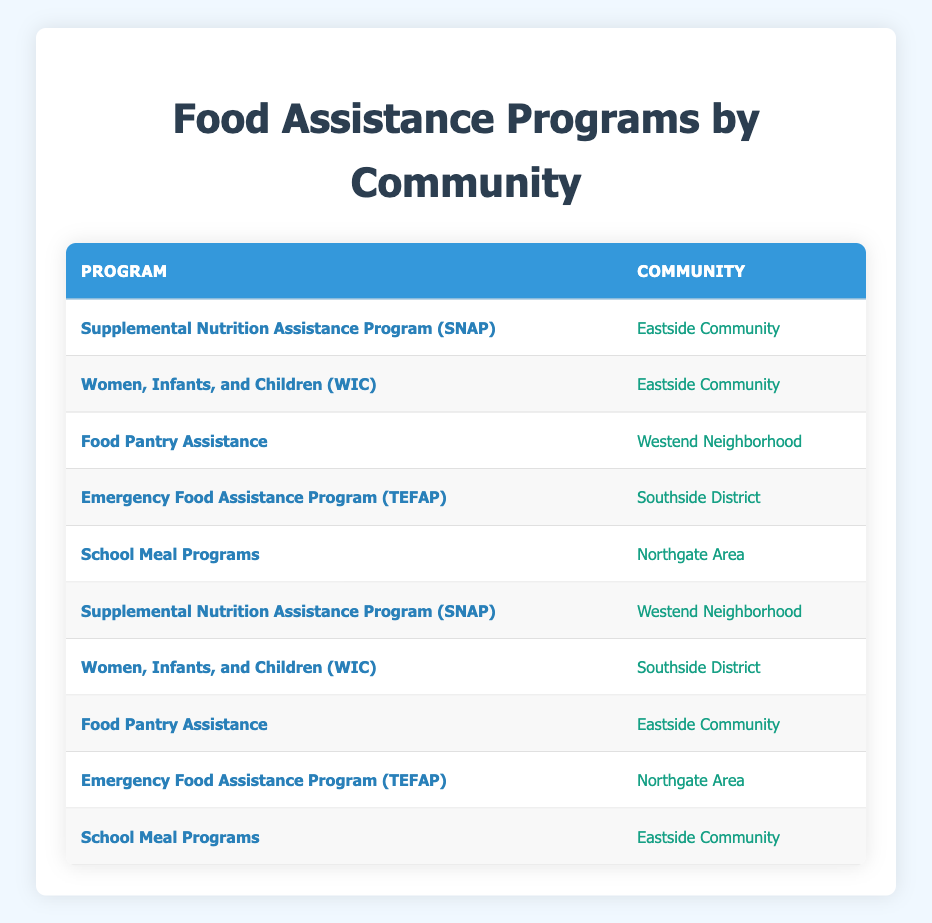What is the most utilized food assistance program in the table? The table lists several food assistance programs, and counting them shows that the "Supplemental Nutrition Assistance Program (SNAP)" appears twice, while all other programs appear once. Therefore, SNAP is the most utilized program.
Answer: Supplemental Nutrition Assistance Program (SNAP) How many households in the Eastside Community are using the "Women, Infants, and Children (WIC)" program? The table shows that "Women, Infants, and Children (WIC)" is listed once under the Eastside Community, indicating that only one household in that community is using this program.
Answer: 1 Are there any households utilizing food assistance programs in the Northgate Area? Yes, the table shows that the "School Meal Programs" and "Emergency Food Assistance Program (TEFAP)" are both used by households in the Northgate Area.
Answer: Yes Which community has the most varied range of food assistance programs utilized? Counting the different programs in each community, the Eastside Community has three different programs ("SNAP," "WIC," and "Food Pantry Assistance"), while the other communities have fewer. Therefore, Eastside has the most variety in food assistance programs.
Answer: Eastside Community How many different food assistance programs are listed in total in the table? The table displays a total of five unique programs: "Supplemental Nutrition Assistance Program (SNAP)", "Women, Infants, and Children (WIC)", "Food Pantry Assistance," "Emergency Food Assistance Program (TEFAP)," and "School Meal Programs." Thus, there are five different programs listed.
Answer: 5 Does the Westend Neighborhood utilize the "School Meal Programs"? No, the table does not indicate that the Westend Neighborhood has any households using the "School Meal Programs." The only programs listed for this community are "Food Pantry Assistance" and "SNAP."
Answer: No What is the total number of households utilizing "Emergency Food Assistance Program (TEFAP)" across all communities? The table shows that "Emergency Food Assistance Program (TEFAP)" is listed twice—once for the Southside District and once for the Northgate Area. Adding these two instances gives us a total of two households using this program.
Answer: 2 Which food assistance program is the only one to appear in the Southside District? The table indicates that "Women, Infants, and Children (WIC)" is the only food assistance program listed for the Southside District. Other programs listed do not appear in that community.
Answer: Women, Infants, and Children (WIC) 